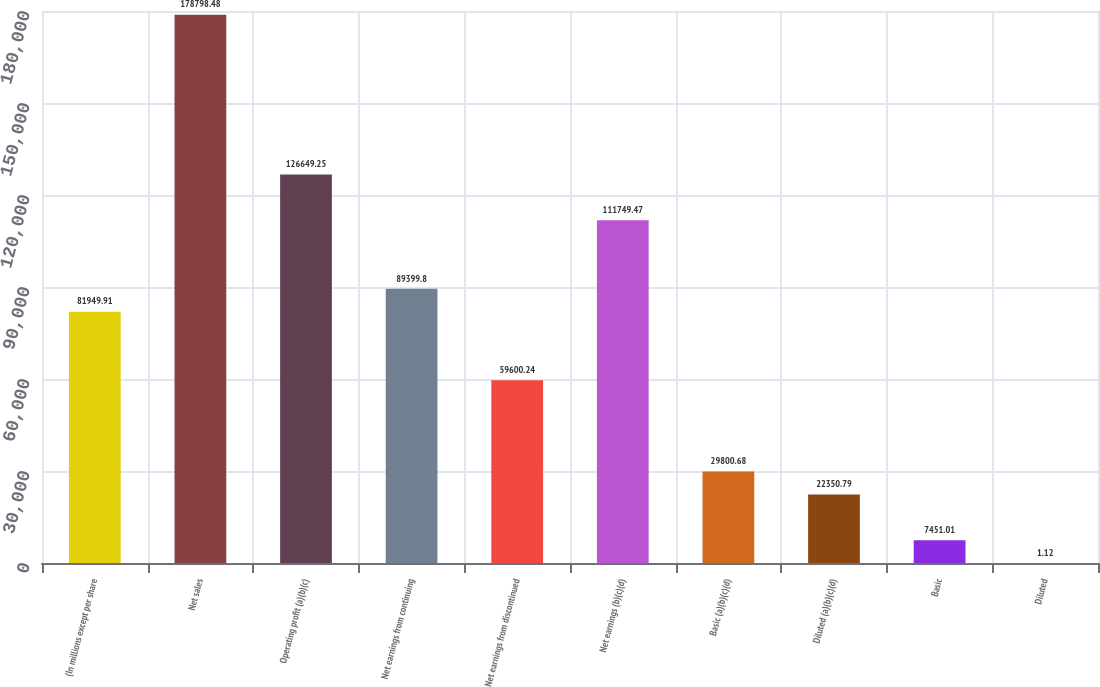Convert chart. <chart><loc_0><loc_0><loc_500><loc_500><bar_chart><fcel>(In millions except per share<fcel>Net sales<fcel>Operating profit (a)(b)(c)<fcel>Net earnings from continuing<fcel>Net earnings from discontinued<fcel>Net earnings (b)(c)(d)<fcel>Basic (a)(b)(c)(d)<fcel>Diluted (a)(b)(c)(d)<fcel>Basic<fcel>Diluted<nl><fcel>81949.9<fcel>178798<fcel>126649<fcel>89399.8<fcel>59600.2<fcel>111749<fcel>29800.7<fcel>22350.8<fcel>7451.01<fcel>1.12<nl></chart> 